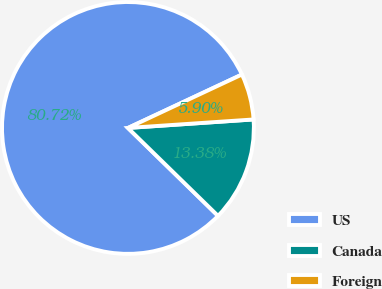<chart> <loc_0><loc_0><loc_500><loc_500><pie_chart><fcel>US<fcel>Canada<fcel>Foreign<nl><fcel>80.72%<fcel>13.38%<fcel>5.9%<nl></chart> 